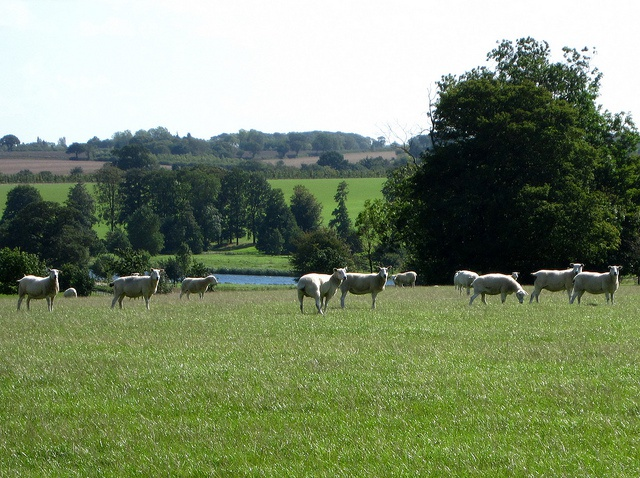Describe the objects in this image and their specific colors. I can see sheep in white, gray, black, and darkgreen tones, sheep in white, black, and gray tones, sheep in white, black, gray, and darkgreen tones, sheep in white, black, gray, and darkgreen tones, and sheep in white, black, and gray tones in this image. 